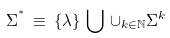Convert formula to latex. <formula><loc_0><loc_0><loc_500><loc_500>\Sigma ^ { ^ { * } } \, \equiv \, \{ \lambda \} \, \bigcup \, \cup _ { k \in { \mathbb { N } } } \Sigma ^ { k }</formula> 